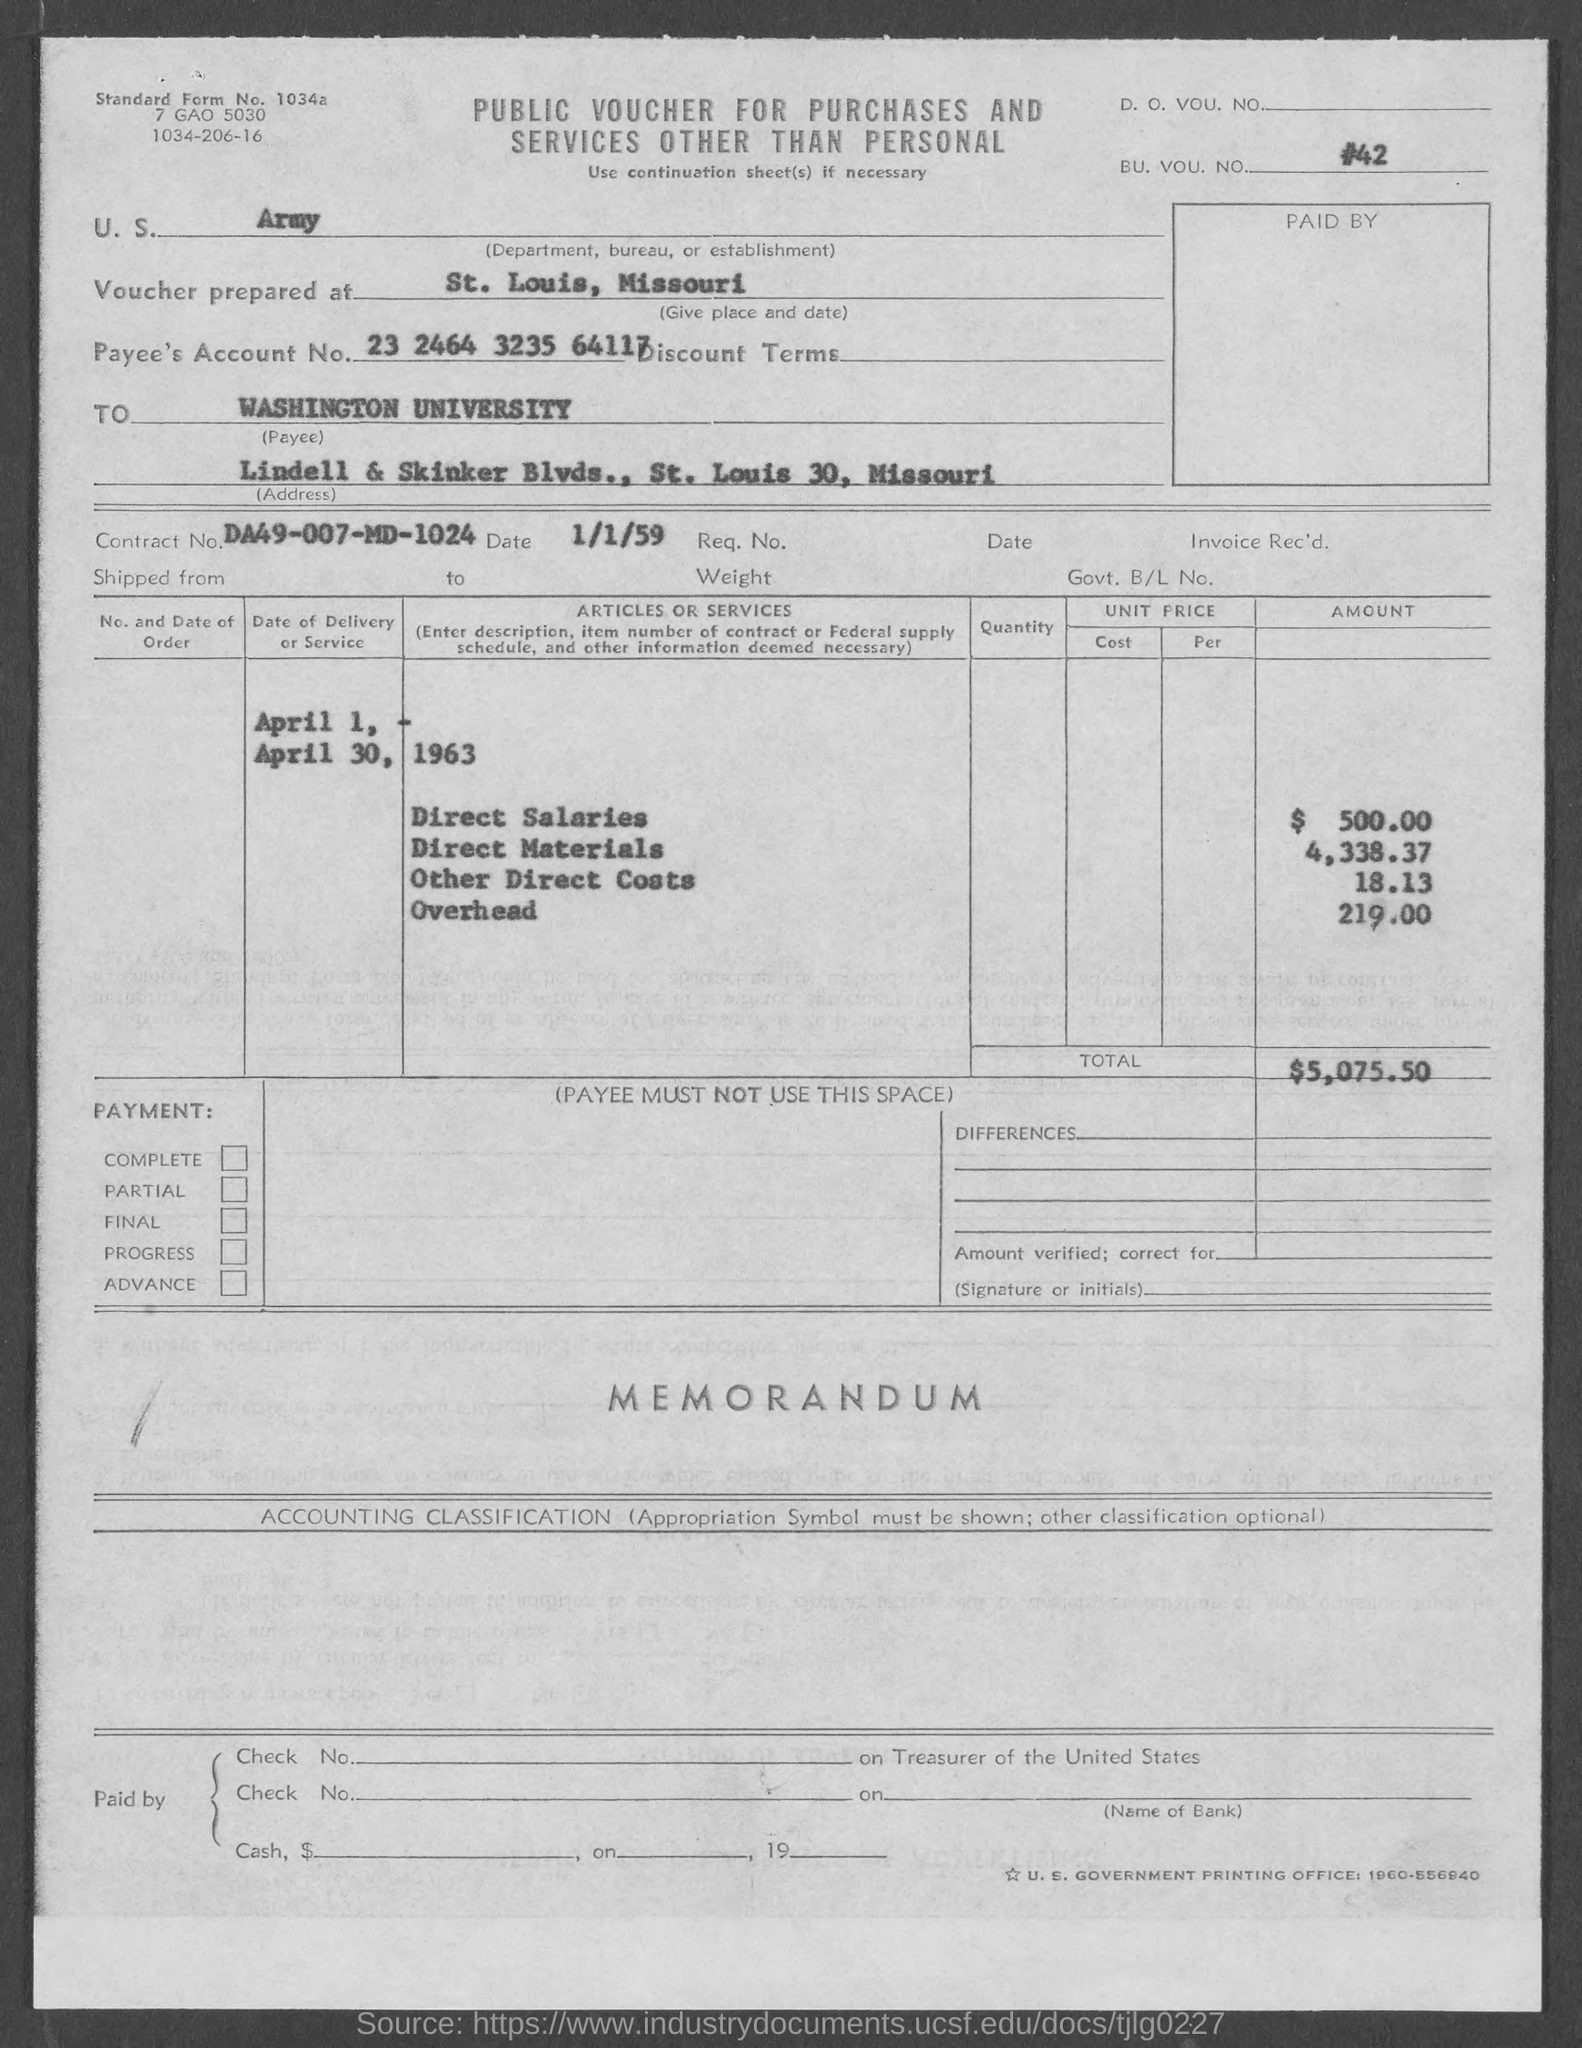List a handful of essential elements in this visual. The voucher contains a Contract No. of DA49-007-MD-1024. The voucher was prepared at St. Louis, Missouri. The direct salaries cost mentioned in the voucher is $500.00. The voucher mentions a BU. VOU. NO. Please see voucher number #42... The payee's account number provided in the voucher is 23 2464 3235 64117. 